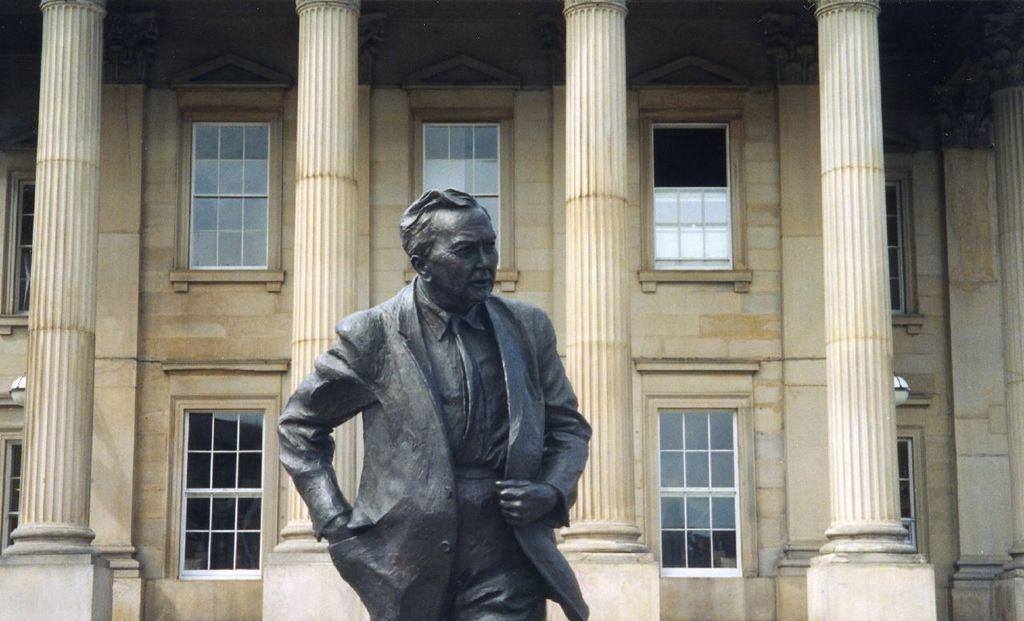Describe this image in one or two sentences. In this picture we can see a statue of a man. In the background of the image we can see pillars and windows. 